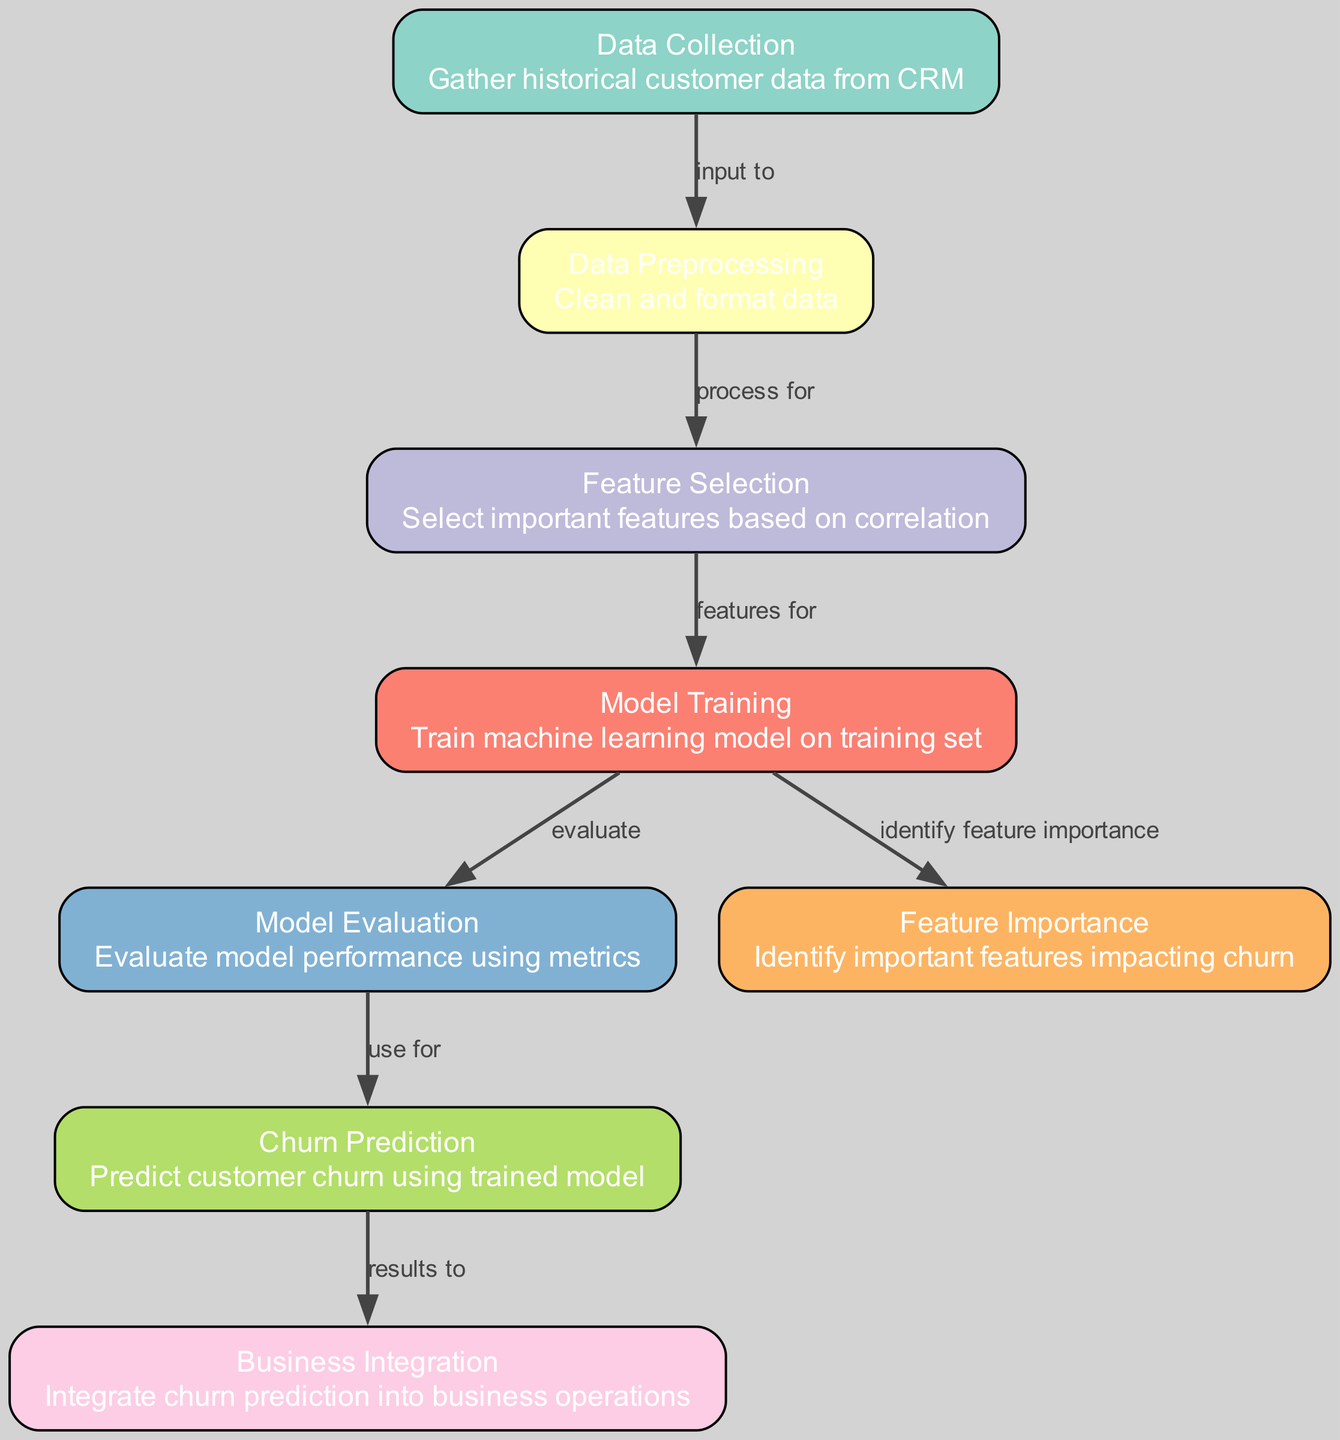What's the total number of nodes in the diagram? Count the number of distinct labels in the nodes list. There are eight nodes labeled from "Data Collection" to "Business Integration."
Answer: 8 What is the label of node 4? Look at the nodes list and find the entry with the id "4." It is labeled "Model Training."
Answer: Model Training What is the input node in the diagram? Review the diagram to identify the first node, which is the starting point of the process. The first node is "Data Collection."
Answer: Data Collection Which node is connected to "Model Evaluation"? Trace the edges to see which node points to "Model Evaluation." The edge from "Model Training" to "Model Evaluation" indicates it is the preceding node.
Answer: Model Training How many edges are there in the diagram? Count the number of connections (edges) listed. There are seven edges described connecting the various nodes.
Answer: 7 What is the purpose of the "Feature Importance" node? Read the description of the "Feature Importance" node. It states that it "identifies important features impacting churn."
Answer: Identify important features What is the relationship between "Model Training" and "Model Evaluation"? Check the edge connecting these nodes. "Model Training" evaluates the performance of the machine learning model in "Model Evaluation."
Answer: Evaluate Which node follows "Churn Prediction" in the flow? Reference the outgoing edge from "Churn Prediction." It points to "Business Integration," indicating that is the subsequent step in the process.
Answer: Business Integration What critical action occurs at the "Feature Selection" node? Assess the description of "Feature Selection" to understand its function. It states that it selects important features based on correlation.
Answer: Select important features 